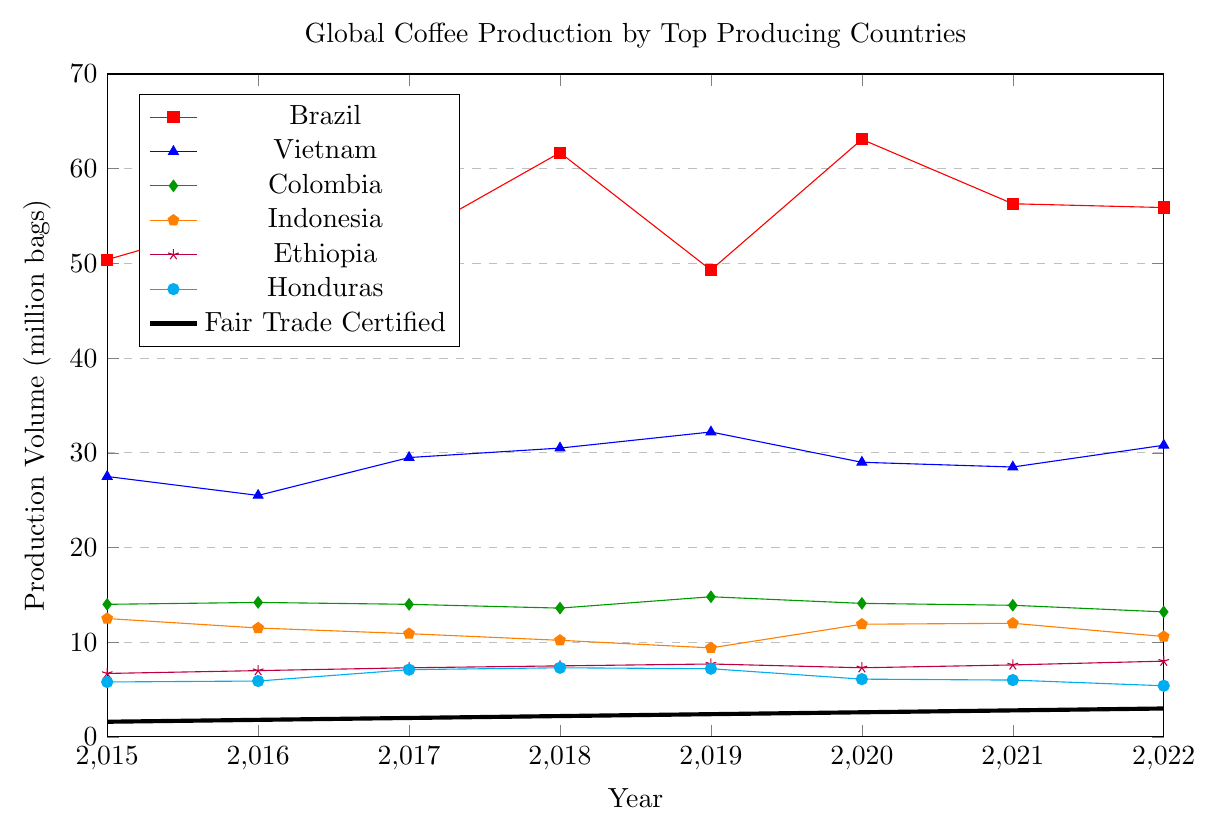What's the total coffee production volume for Brazil and Vietnam in 2022? Adding the coffee production volumes for Brazil and Vietnam in 2022, we have 55.9 (Brazil) + 30.8 (Vietnam) = 86.7 million bags.
Answer: 86.7 Which country had the lowest coffee production volume in 2019? Comparing the coffee production volumes in 2019, the values are: Brazil (49.3), Vietnam (32.2), Colombia (14.8), Indonesia (9.4), Ethiopia (7.7), Honduras (7.2), and Fair Trade Certified (2.4). The lowest value is from Fair Trade Certified with 2.4 million bags.
Answer: Fair Trade Certified What was the trend in Fair Trade certified coffee production from 2015 to 2022? Observing the Fair Trade Certified production data, we see a consistent increase over the years: 1.6 (2015), 1.8 (2016), 2.0 (2017), 2.2 (2018), 2.4 (2019), 2.6 (2020), 2.8 (2021), 3.0 (2022). This indicates a steady upward trend in Fair Trade production.
Answer: Increasing In which year did Indonesia's coffee production volume see its lowest point? By comparing Indonesia's production volumes across the years: 12.5 (2015), 11.5 (2016), 10.9 (2017), 10.2 (2018), 9.4 (2019), 11.9 (2020), 12.0 (2021), 10.6 (2022), we see the lowest value is 9.4 in 2019.
Answer: 2019 How did the production volumes of Ethiopia and Honduras compare in 2017? The production volume for Ethiopia in 2017 is 7.3 million bags and for Honduras, it is 7.1 million bags. Ethiopia produced slightly more coffee than Honduras in 2017.
Answer: Ethiopia produced more What is the average coffee production volume for Colombia between 2015 and 2018? Adding the values for Colombia from 2015 to 2018, we have: 14.0 (2015) + 14.2 (2016) + 14.0 (2017) + 13.6 (2018) = 55.8. Dividing by the number of years (4), the average is 55.8 / 4 = 13.95 million bags.
Answer: 13.95 Which country had the highest coffee production volume in 2020? Comparing the production values in 2020: Brazil (63.1), Vietnam (29.0), Colombia (14.1), Indonesia (11.9), Ethiopia (7.3), Honduras (6.1), Fair Trade Certified (2.6), Brazil has the highest volume with 63.1 million bags.
Answer: Brazil What is the difference in coffee production volumes between the highest and lowest producing countries in 2021? In 2021, Brazil had the highest production volume (56.3 million bags) and Fair Trade Certified had the lowest (2.8 million bags). The difference is 56.3 - 2.8 = 53.5 million bags.
Answer: 53.5 Among the given countries, which one had the most consistent production from 2015 to 2022? Evaluating the data for consistency, Colombia's production volumes: 14.0 (2015), 14.2 (2016), 14.0 (2017), 13.6 (2018), 14.8 (2019), 14.1 (2020), 13.9 (2021), 13.2 (2022) showcase the least variability and most consistency among the given countries.
Answer: Colombia 